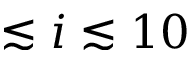<formula> <loc_0><loc_0><loc_500><loc_500>\lesssim i \lesssim 1 0</formula> 